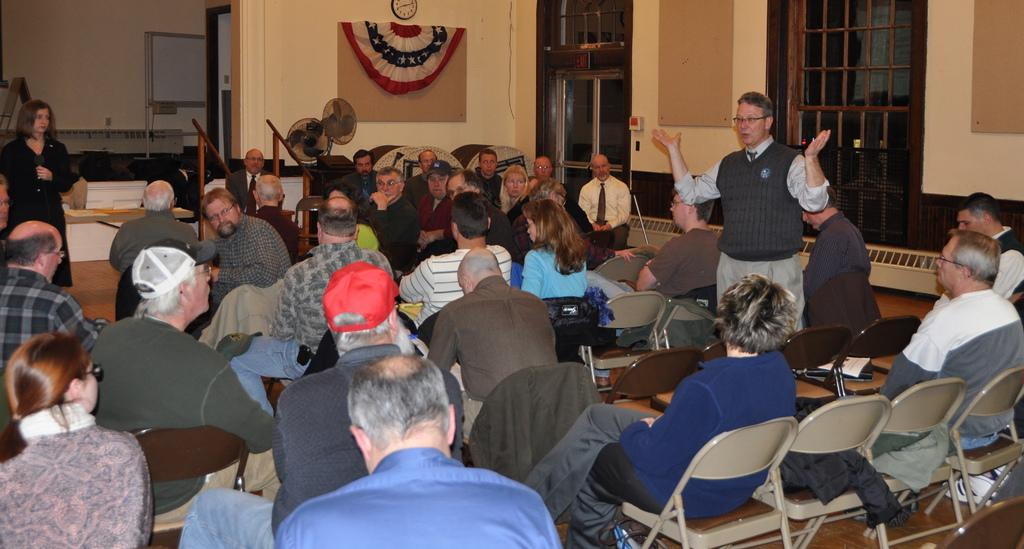What are the people in the image doing? The people in the image are sitting on chairs. What can be seen in the background of the image? There are table fans, a clock on the wall, and glass windows in the background of the image. What type of protest is happening outside the glass windows in the image? There is no protest visible in the image; it only shows people sitting on chairs and the background details mentioned earlier. 